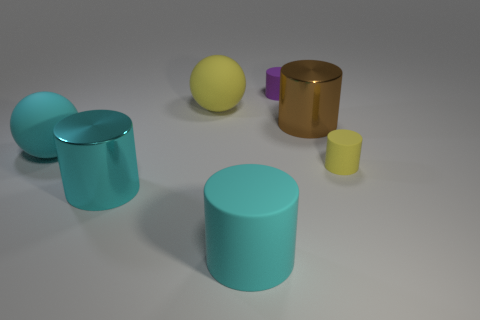Are there any other things that have the same shape as the big yellow thing?
Provide a short and direct response. Yes. What size is the ball right of the cyan metal cylinder?
Offer a terse response. Large. How many other things are the same color as the big rubber cylinder?
Give a very brief answer. 2. There is a big cylinder behind the yellow cylinder that is in front of the purple cylinder; what is its material?
Your answer should be very brief. Metal. There is a matte ball that is in front of the brown metal object; is it the same color as the large matte cylinder?
Your answer should be compact. Yes. What number of tiny purple things are the same shape as the large brown shiny object?
Your answer should be compact. 1. There is a cyan sphere that is the same material as the big yellow sphere; what size is it?
Your answer should be compact. Large. Is there a large yellow rubber thing behind the rubber cylinder behind the big matte thing behind the brown metallic cylinder?
Your answer should be very brief. No. There is a yellow matte object left of the yellow cylinder; is it the same size as the purple rubber cylinder?
Keep it short and to the point. No. What number of yellow rubber cylinders have the same size as the brown shiny thing?
Keep it short and to the point. 0. 